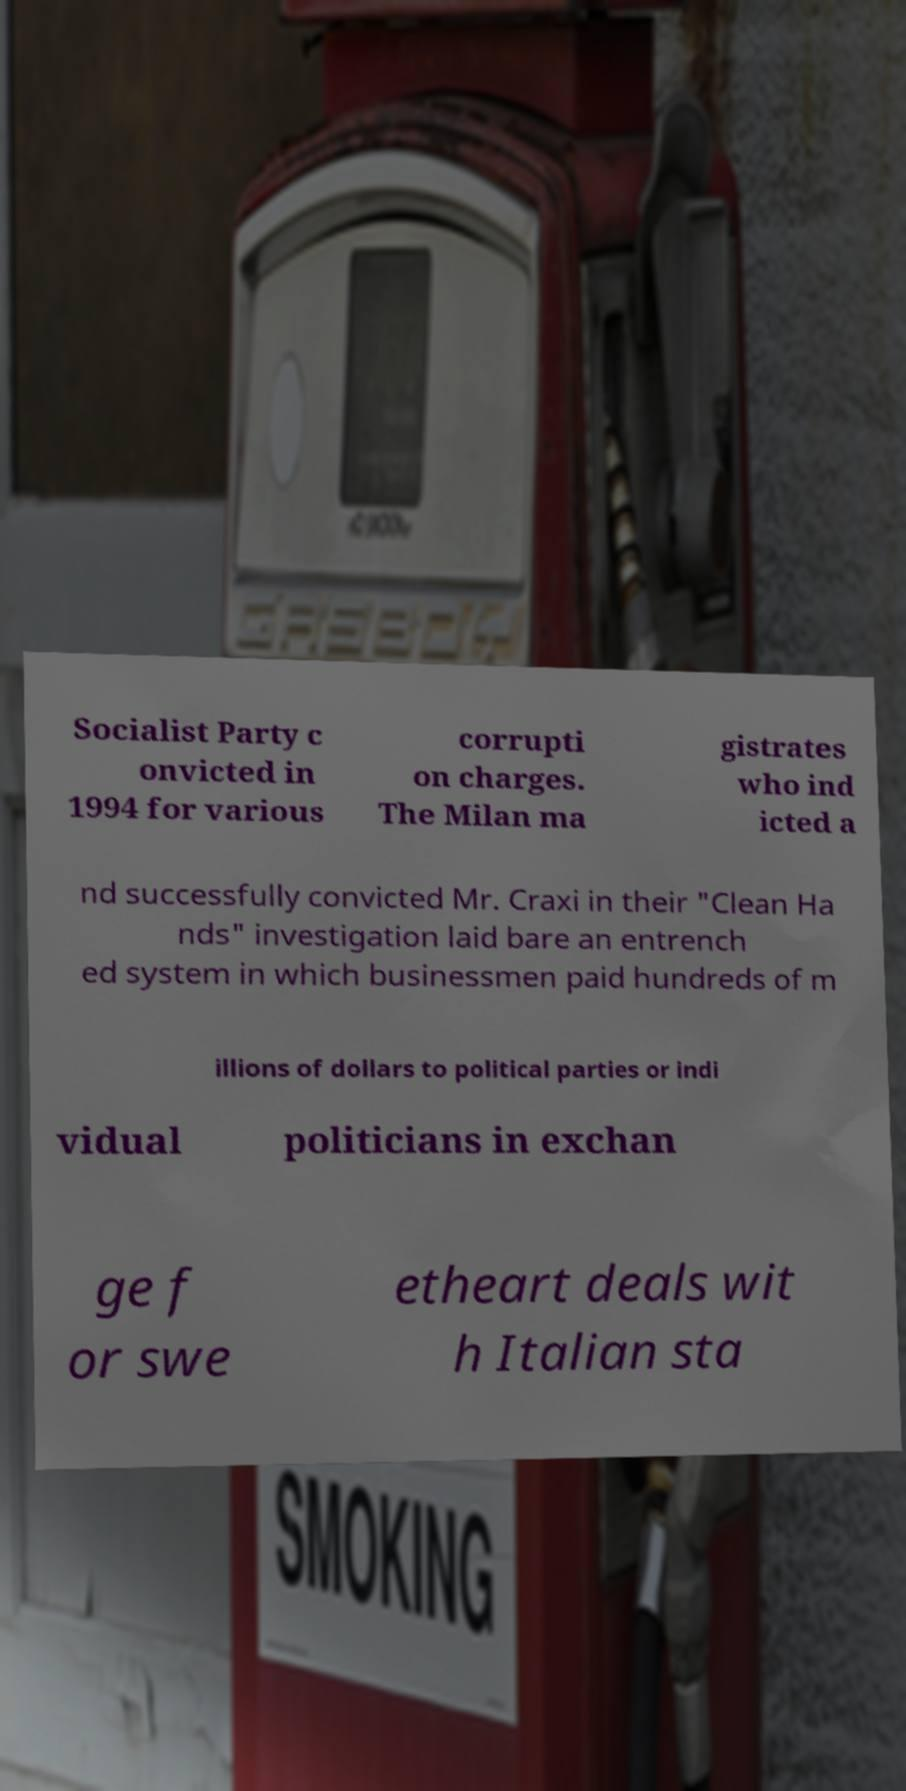Can you read and provide the text displayed in the image?This photo seems to have some interesting text. Can you extract and type it out for me? Socialist Party c onvicted in 1994 for various corrupti on charges. The Milan ma gistrates who ind icted a nd successfully convicted Mr. Craxi in their "Clean Ha nds" investigation laid bare an entrench ed system in which businessmen paid hundreds of m illions of dollars to political parties or indi vidual politicians in exchan ge f or swe etheart deals wit h Italian sta 